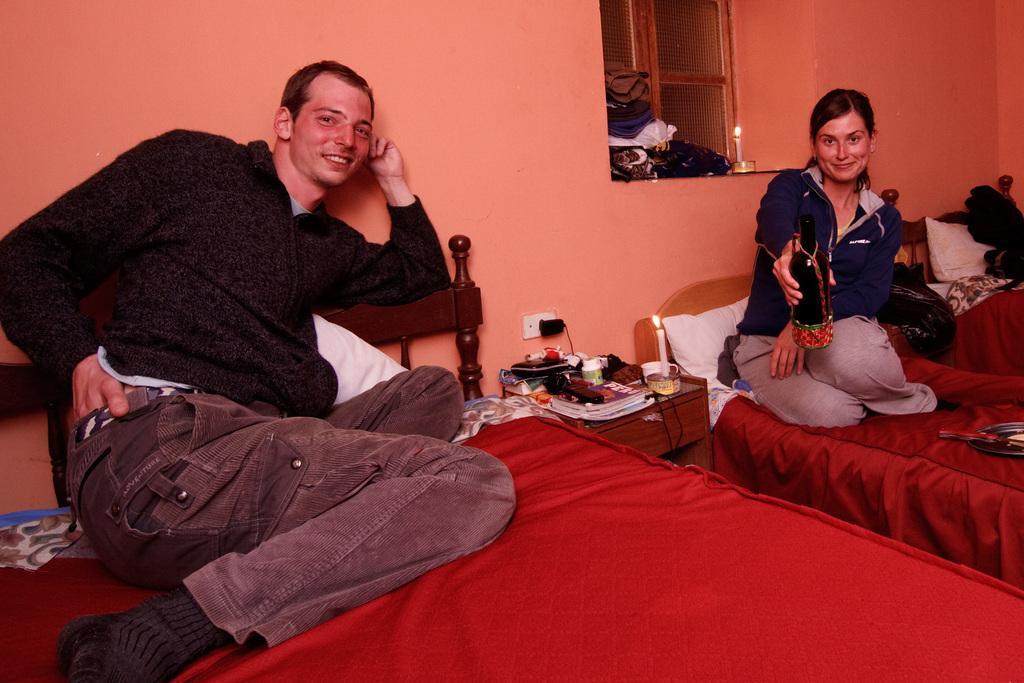Could you give a brief overview of what you see in this image? In this picture i could see two persons sitting on the bed which is red in color. In the background there is orange color wall and a glass window and on the table there are some books candles and some other stuff. 